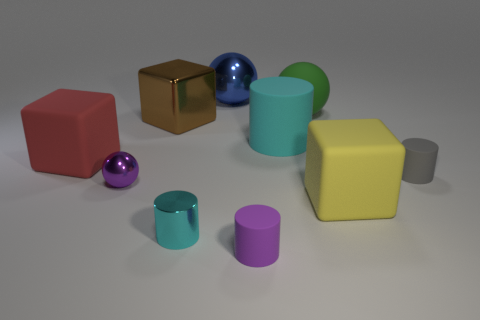Does the large matte thing on the left side of the cyan matte cylinder have the same shape as the yellow rubber thing that is right of the green thing?
Your answer should be very brief. Yes. What number of objects are red things or big rubber things behind the large brown metallic object?
Offer a terse response. 2. What is the material of the cylinder that is on the right side of the tiny purple matte cylinder and on the left side of the gray object?
Keep it short and to the point. Rubber. Are there any other things that are the same shape as the small gray rubber object?
Make the answer very short. Yes. The big block that is the same material as the large red thing is what color?
Your answer should be compact. Yellow. How many objects are either small green shiny objects or purple rubber cylinders?
Give a very brief answer. 1. Do the brown thing and the purple object in front of the yellow rubber thing have the same size?
Your response must be concise. No. The small cylinder that is behind the cyan object that is in front of the small gray rubber object that is in front of the large green sphere is what color?
Your answer should be compact. Gray. What color is the big metallic sphere?
Your answer should be very brief. Blue. Are there more big cyan things behind the large yellow matte thing than gray matte cylinders that are right of the gray matte thing?
Offer a terse response. Yes. 